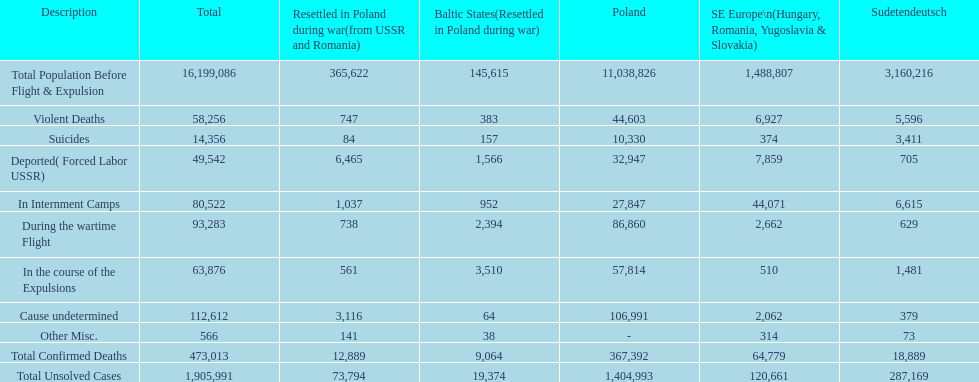Before expulsion occurred, did poland or sudetendeutsch have a larger overall population? Poland. 